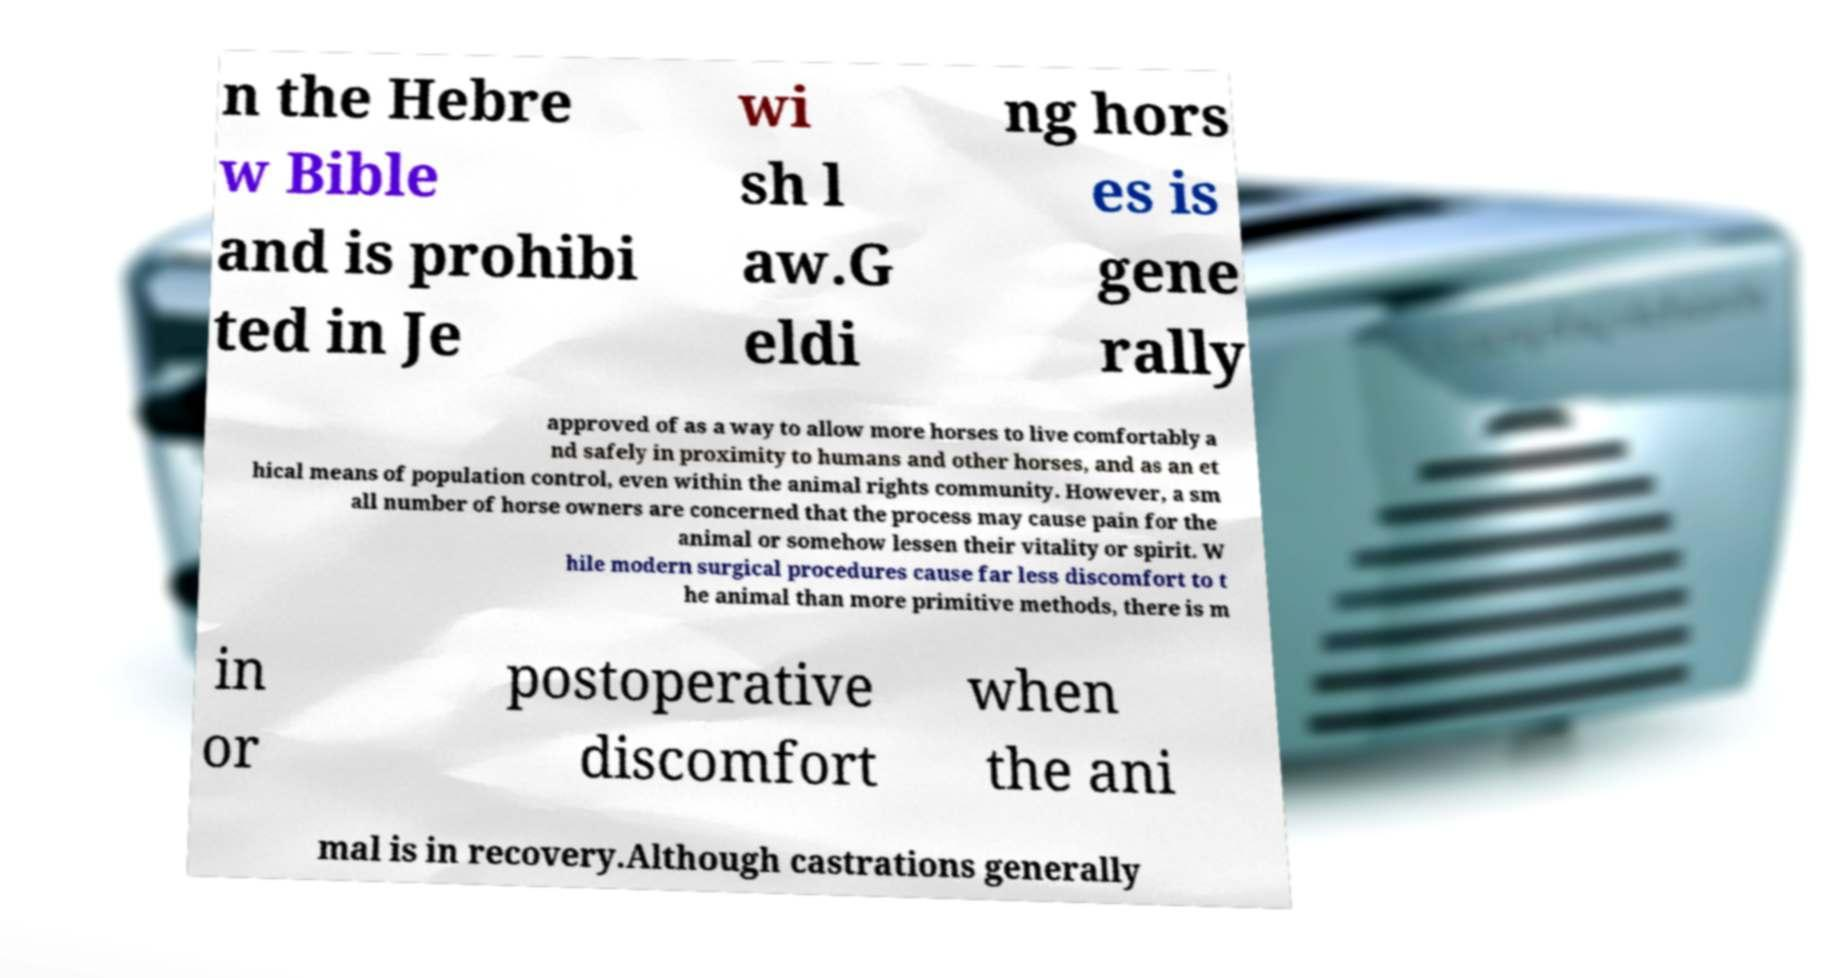Please identify and transcribe the text found in this image. n the Hebre w Bible and is prohibi ted in Je wi sh l aw.G eldi ng hors es is gene rally approved of as a way to allow more horses to live comfortably a nd safely in proximity to humans and other horses, and as an et hical means of population control, even within the animal rights community. However, a sm all number of horse owners are concerned that the process may cause pain for the animal or somehow lessen their vitality or spirit. W hile modern surgical procedures cause far less discomfort to t he animal than more primitive methods, there is m in or postoperative discomfort when the ani mal is in recovery.Although castrations generally 